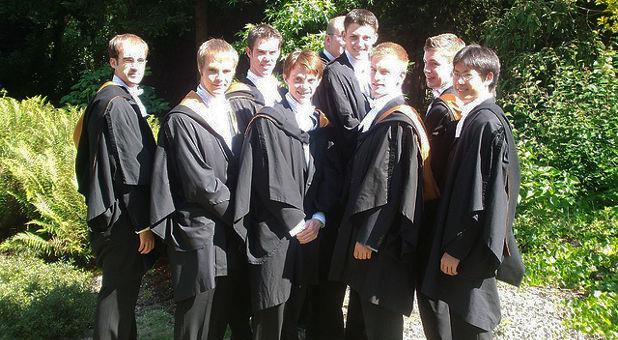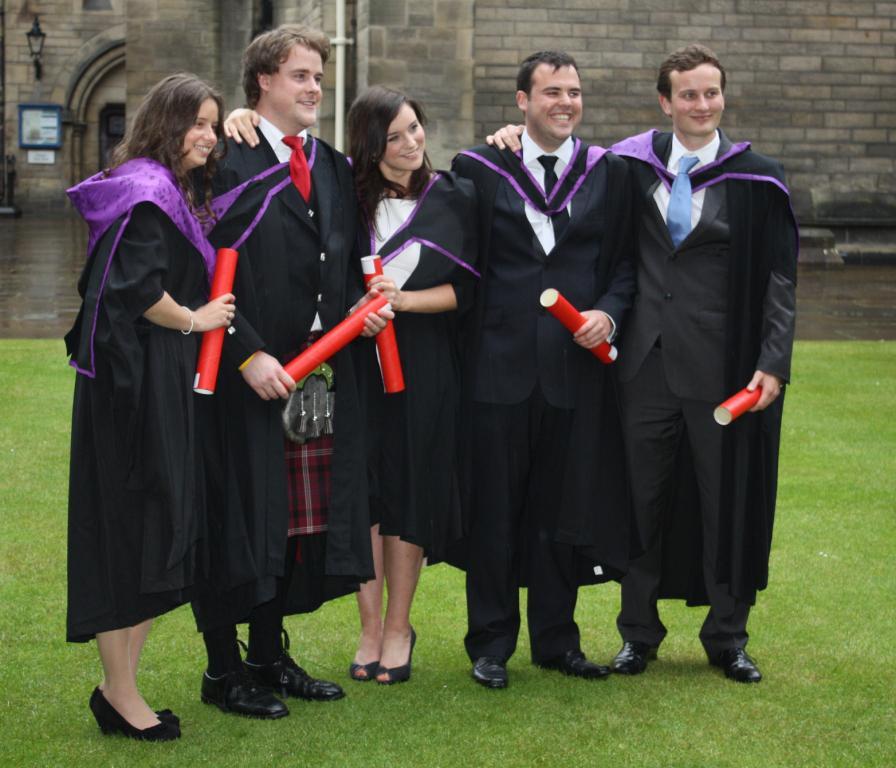The first image is the image on the left, the second image is the image on the right. Assess this claim about the two images: "Right image shows multiple graduates holding red rolled items, and includes a fellow in a kilt.". Correct or not? Answer yes or no. Yes. The first image is the image on the left, the second image is the image on the right. Evaluate the accuracy of this statement regarding the images: "In each image, at least one black-robed graduate is holding a diploma in a red tube, while standing in front of a large stone building.". Is it true? Answer yes or no. No. 